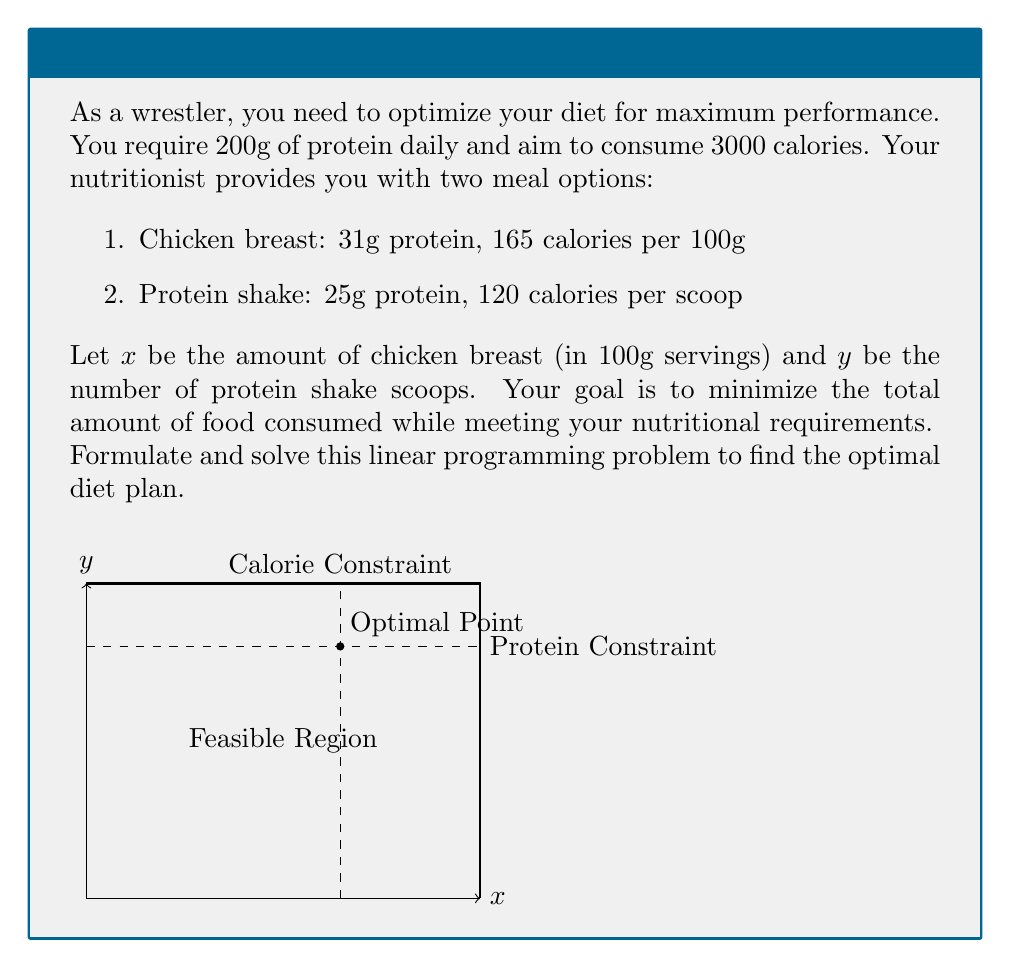Provide a solution to this math problem. Let's approach this step-by-step:

1) First, we need to set up our constraints:

   Protein constraint: $31x + 25y \geq 200$
   Calorie constraint: $165x + 120y \leq 3000$

2) Our objective function is to minimize the total amount of food:

   Minimize $z = x + y$

3) We also need non-negativity constraints:

   $x \geq 0$, $y \geq 0$

4) To solve this, we'll use the graphical method. We'll plot our constraints:

   From protein constraint: $y \geq \frac{200 - 31x}{25}$
   From calorie constraint: $y \leq 25 - \frac{11x}{8}$

5) The feasible region is the area that satisfies all constraints.

6) The optimal solution will be at one of the corner points of this region.

7) The corner points are:
   - (0, 8) [intersection of y-axis and protein constraint]
   - (6.45, 6.4) [intersection of protein and calorie constraints]
   - (10, 0) [intersection of x-axis and calorie constraint]

8) Evaluating our objective function at these points:
   - z(0, 8) = 8
   - z(6.45, 6.4) = 12.85
   - z(10, 0) = 10

9) The minimum value is at (0, 8), but this doesn't meet the protein requirement.

10) Therefore, the optimal solution is at (6.45, 6.4).

11) Rounding to the nearest whole number (as we can't have fractional servings):
    x = 6 (100g servings of chicken breast)
    y = 6 (scoops of protein shake)
Answer: 6 servings of chicken breast and 6 scoops of protein shake 